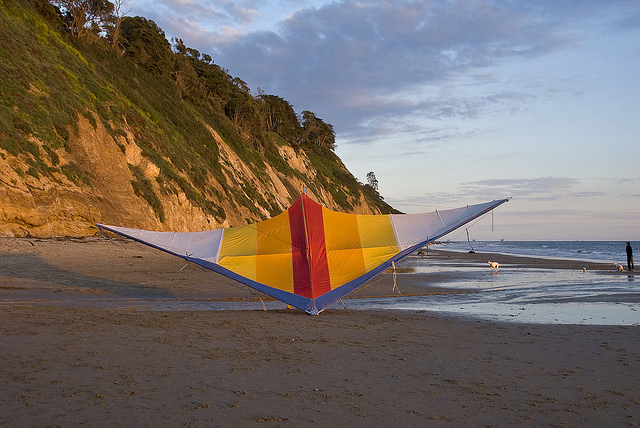Is there a hang glider in the image? No, there isn’t a hang glider present in the image. The main focus is on a large kite that is resting on the beach. 